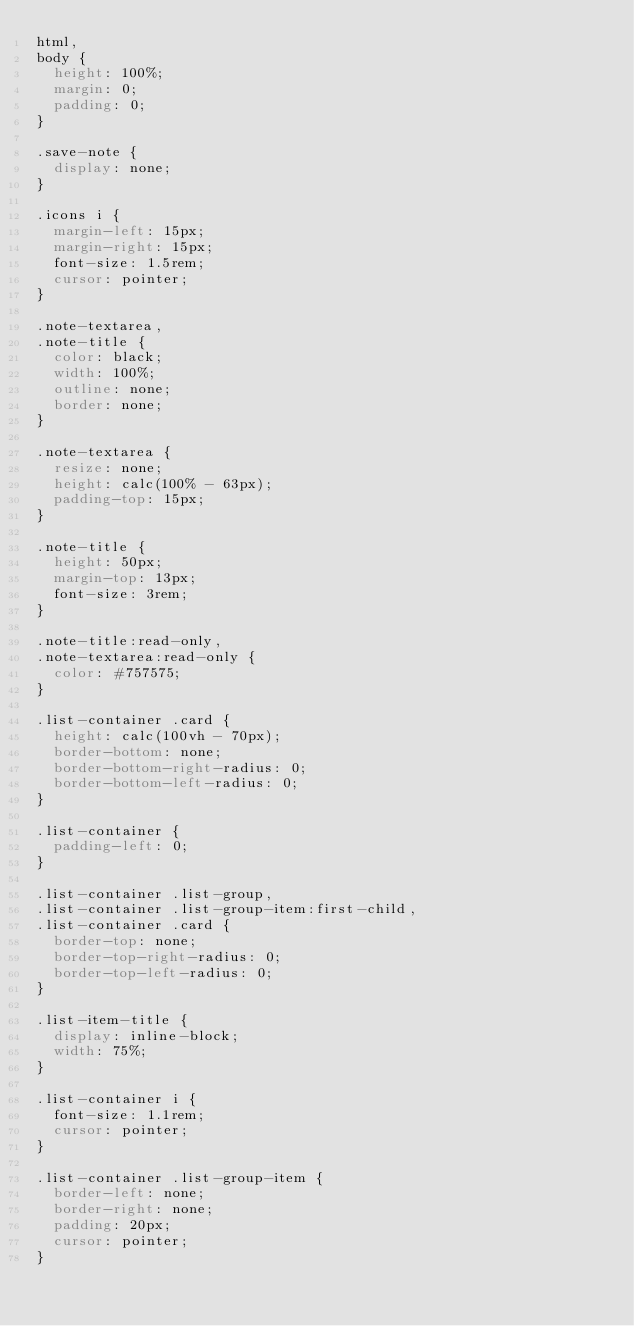<code> <loc_0><loc_0><loc_500><loc_500><_CSS_>html,
body {
  height: 100%;
  margin: 0;
  padding: 0;
}

.save-note {
  display: none;
}

.icons i {
  margin-left: 15px;
  margin-right: 15px;
  font-size: 1.5rem;
  cursor: pointer;
}

.note-textarea,
.note-title {
  color: black;
  width: 100%;
  outline: none;
  border: none;
}

.note-textarea {
  resize: none;
  height: calc(100% - 63px);
  padding-top: 15px;
}

.note-title {
  height: 50px;
  margin-top: 13px;
  font-size: 3rem;
}

.note-title:read-only,
.note-textarea:read-only {
  color: #757575;
}

.list-container .card {
  height: calc(100vh - 70px);
  border-bottom: none;
  border-bottom-right-radius: 0;
  border-bottom-left-radius: 0;
}

.list-container {
  padding-left: 0;
}

.list-container .list-group,
.list-container .list-group-item:first-child,
.list-container .card {
  border-top: none;
  border-top-right-radius: 0;
  border-top-left-radius: 0;
}

.list-item-title {
  display: inline-block;
  width: 75%;
}

.list-container i {
  font-size: 1.1rem;
  cursor: pointer;
}

.list-container .list-group-item {
  border-left: none;
  border-right: none;
  padding: 20px;
  cursor: pointer;
}
</code> 